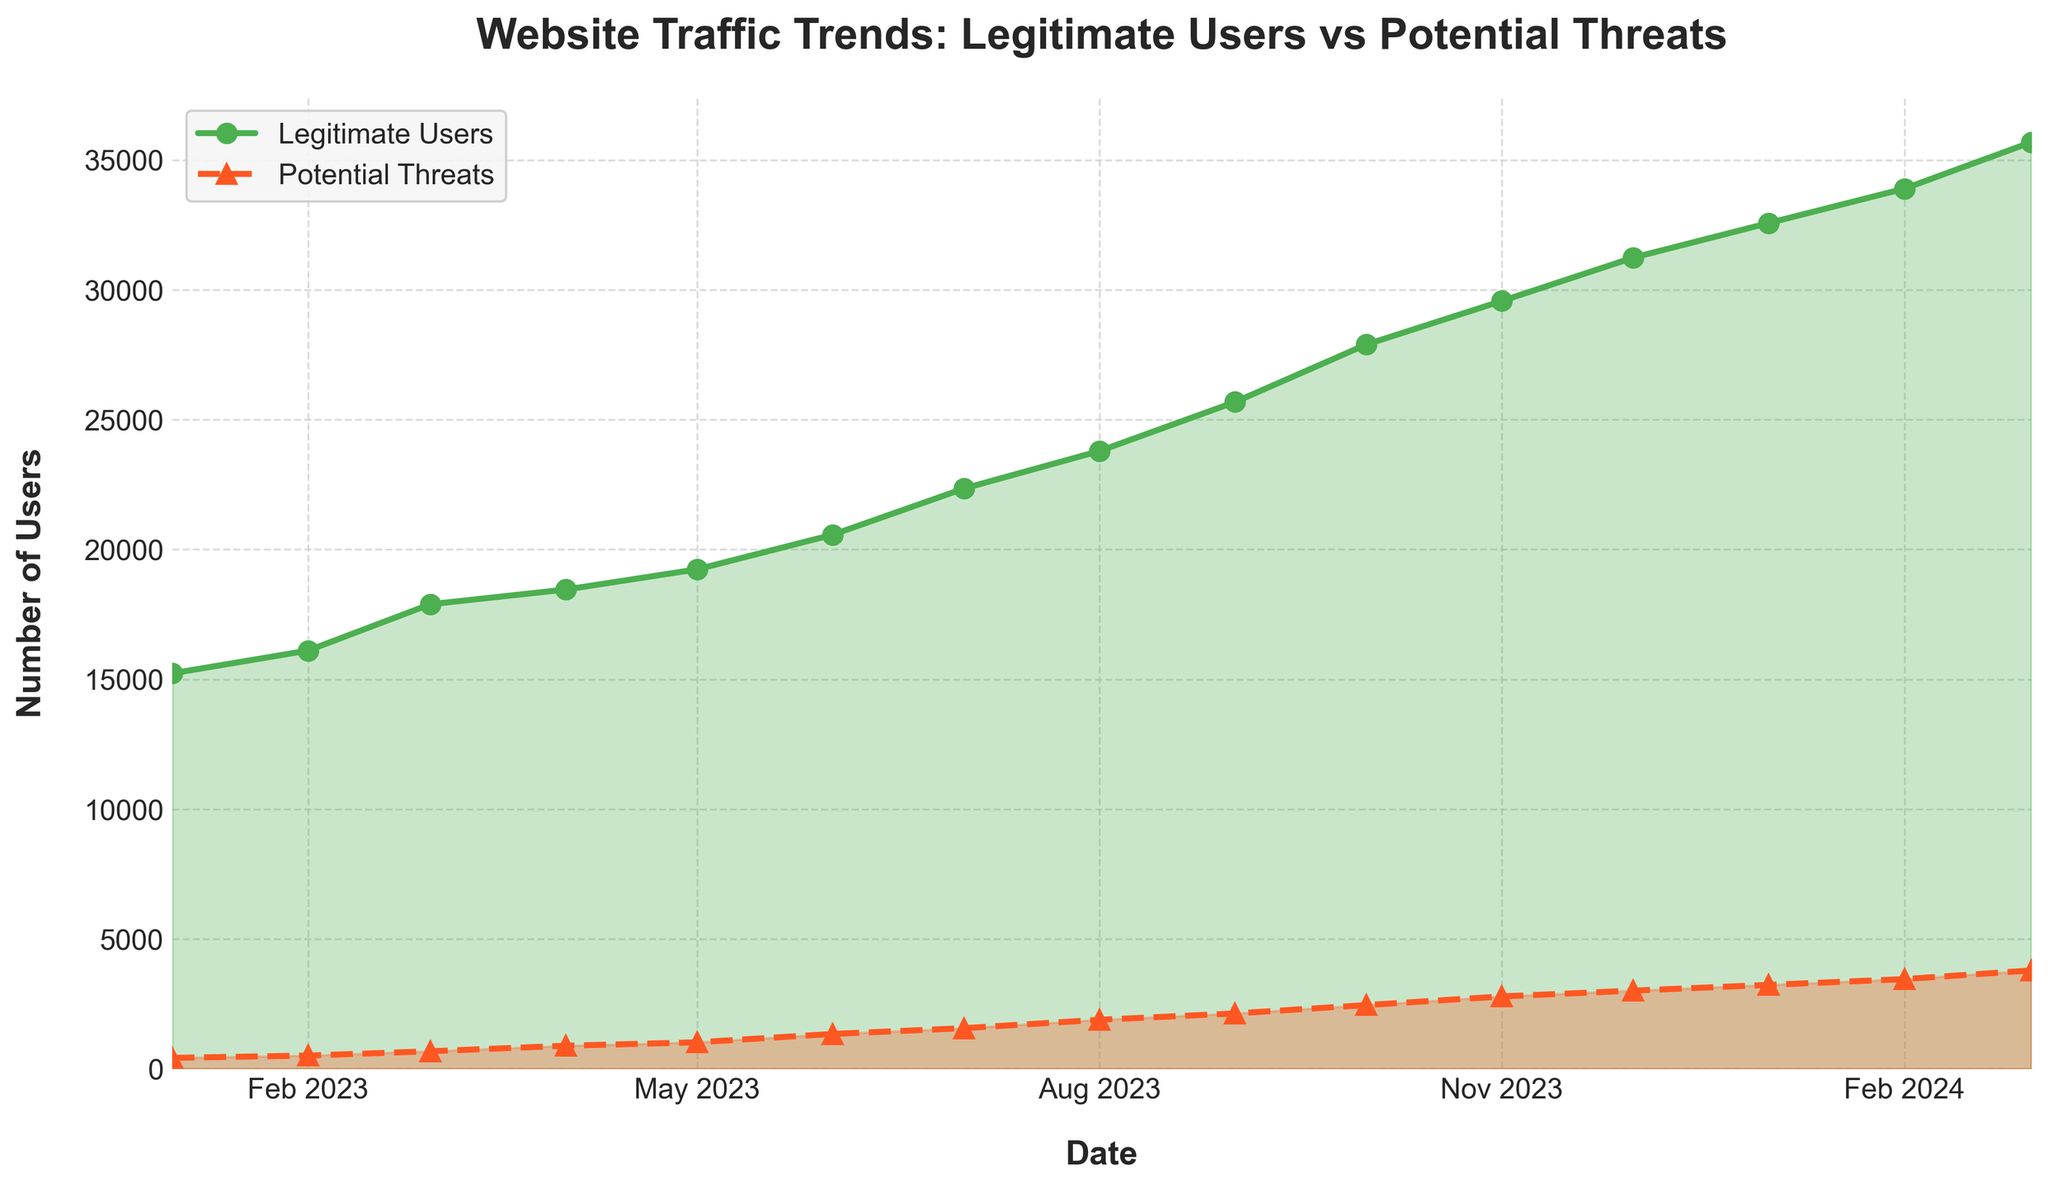When did the number of legitimate users first exceed 20,000? The number of legitimate users is plotted in green. By observing the figures on the y-axis and their corresponding dates, the number of legitimate users first exceeds 20,000 in June 2023.
Answer: June 2023 How many potential threats were there in March 2023 compared to January 2023? The number of potential threats in March 2023 is 678, and in January 2023, it is 423. By subtracting the smaller number from the larger, 678 - 423 = 255, we find that there were 255 more potential threats in March 2023 than January 2023.
Answer: 255 What is the average number of legitimate users over the first six months of 2023? To find the average, add the number of legitimate users for each month from January to June 2023 and then divide by 6. (15230 + 16105 + 17890 + 18456 + 19234 + 20567) / 6 = 107482 / 6 = 17913.667.
Answer: 17913.667 By how much did the number of potential threats increase from June 2023 to December 2023? The number of potential threats in June 2023 is 1345, and in December 2023, it is 3012. Subtracting the initial from the final value, 3012 - 1345 = 1667, the increase is 1667.
Answer: 1667 Which month shows the highest increase in legitimate users compared to the previous month in 2023? To determine the highest increase, calculate the difference in the number of legitimate users between each consecutive month: (Feb-Jan), (Mar-Feb), (Apr-Mar), etc. The highest increase is from June to July 2023: 22345 - 20567 = 1778.
Answer: July 2023 Which curve (legitimate users or potential threats) shows a more consistent upward trend? The curve for legitimate users (green) shows a more consistent upward trend with a steady increase over time, whereas the potential threats curve (red) shows more fluctuations.
Answer: Legitimate users How many legitimate users and potential threats are there on November 1, 2023? By looking at the respective points on the chart indicated for November 2023, the number of legitimate users is 29,567 and potential threats is 2,789.
Answer: Legitimate users: 29,567, Potential threats: 2,789 What color is used to represent potential threats? The chart uses red to represent potential threats.
Answer: Red Which month experienced the highest number of potential threats? By looking at the peak of the red line, the month with the highest number of potential threats is March 2024, which reaches 3789.
Answer: March 2024 On what date did legitimate users surpass 30,000, and did the potential threats follow the same pattern? Legitimate users surpassed 30,000 in December 2023. The potential threats did not follow the same rapid increase, showing a slower and fluctuating rise.
Answer: Legitimate users: December 2023; Potential threats: No similar pattern 